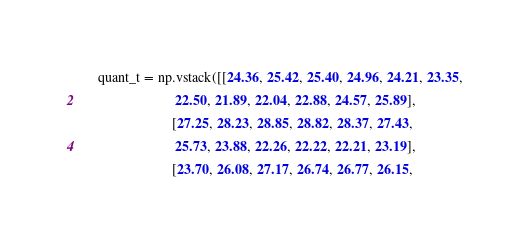Convert code to text. <code><loc_0><loc_0><loc_500><loc_500><_Python_>    quant_t = np.vstack([[24.36, 25.42, 25.40, 24.96, 24.21, 23.35,
                          22.50, 21.89, 22.04, 22.88, 24.57, 25.89],
                         [27.25, 28.23, 28.85, 28.82, 28.37, 27.43,
                          25.73, 23.88, 22.26, 22.22, 22.21, 23.19],
                         [23.70, 26.08, 27.17, 26.74, 26.77, 26.15,</code> 